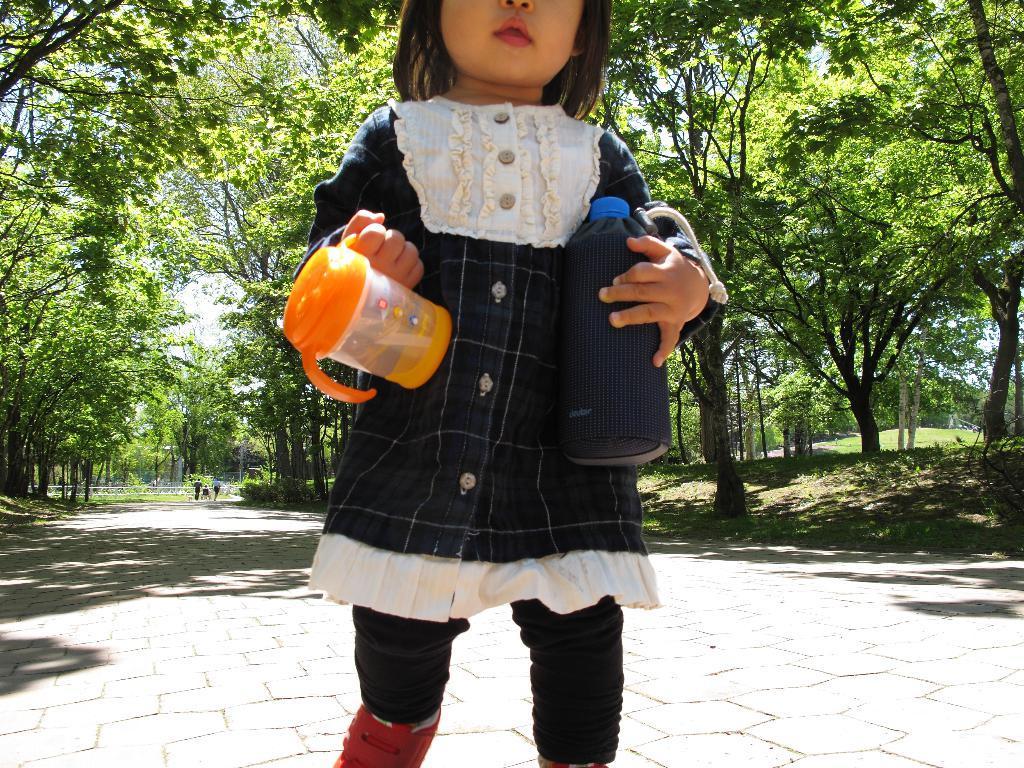In one or two sentences, can you explain what this image depicts? In this image we can see a kid wearing black color dress walking and holding baby sipper and bottle in her hands and at the background of the image there are some trees and some persons walking. 